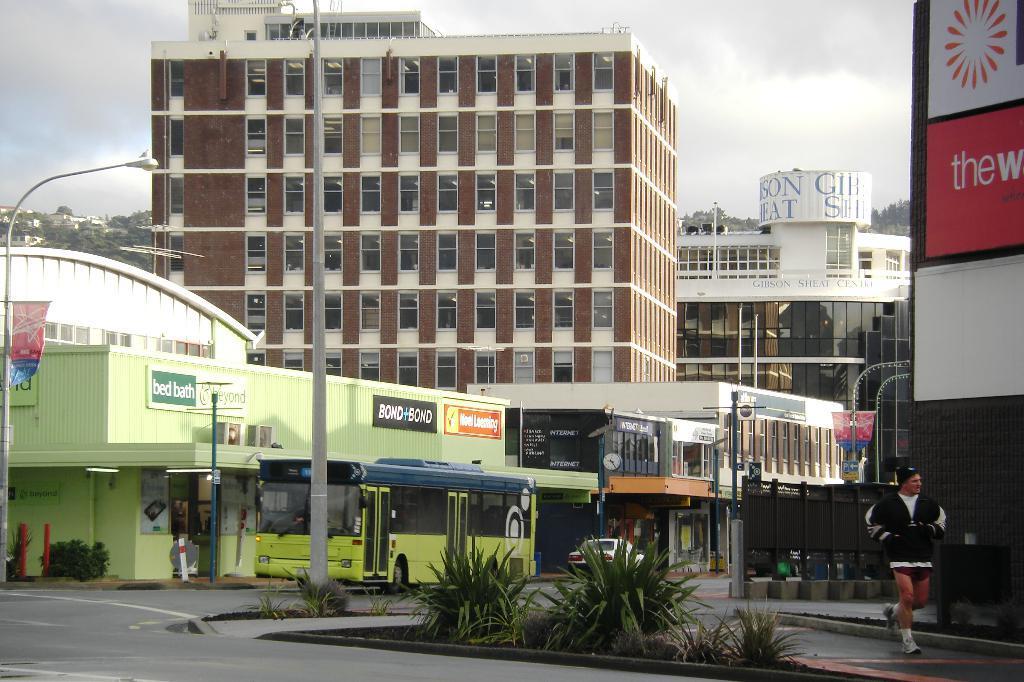In one or two sentences, can you explain what this image depicts? In this image I can see number of buildings, number of poles, number of boards, a bus, a car, few plants and on these boards I can see something is written. On the bottom right side of the image I can see one person is running on the road and on the left side I can see a street light. In the background I can see number of trees, clouds and the sky. 